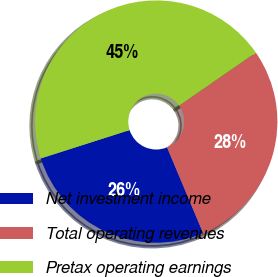<chart> <loc_0><loc_0><loc_500><loc_500><pie_chart><fcel>Net investment income<fcel>Total operating revenues<fcel>Pretax operating earnings<nl><fcel>26.42%<fcel>28.3%<fcel>45.28%<nl></chart> 